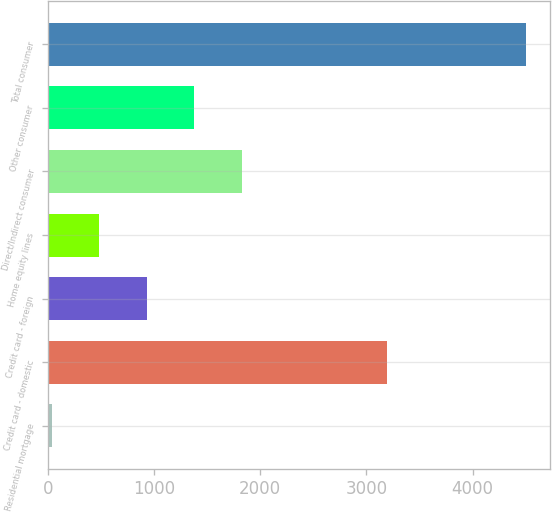Convert chart to OTSL. <chart><loc_0><loc_0><loc_500><loc_500><bar_chart><fcel>Residential mortgage<fcel>Credit card - domestic<fcel>Credit card - foreign<fcel>Home equity lines<fcel>Direct/Indirect consumer<fcel>Other consumer<fcel>Total consumer<nl><fcel>39<fcel>3193<fcel>932.6<fcel>485.8<fcel>1826.2<fcel>1379.4<fcel>4507<nl></chart> 